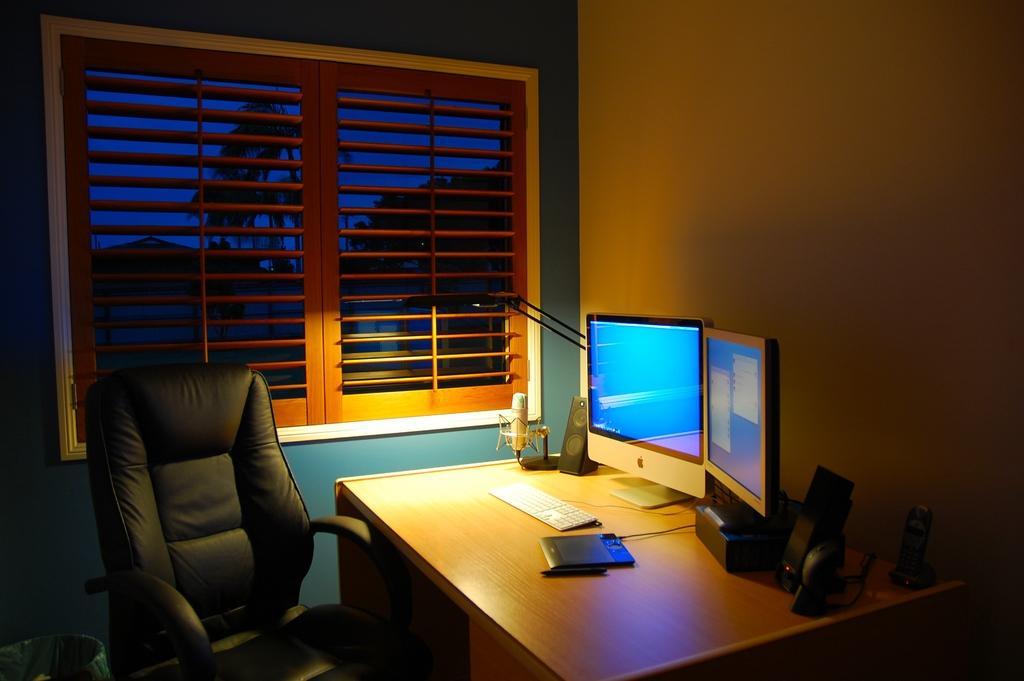What type of furniture is present in the image? There is a chair and a table in the image. What is on top of the table? There is a desktop, paper, a microphone (mic), and a speaker on the table. What can be seen in the background of the image? There is a window in the background of the image. Reasoning: Let'g: Let's think step by step in order to produce the conversation. We start by identifying the main furniture pieces in the image, which are the chair and the table. Then, we describe the items that are on top of the table, including the desktop, paper, microphone, and speaker. Finally, we mention the window visible in the background of the image. Absurd Question/Answer: How many icicles are hanging from the window in the image? There are no icicles present in the image; it only shows a window in the background. Is there a jail visible in the image? There is no jail present in the image. 